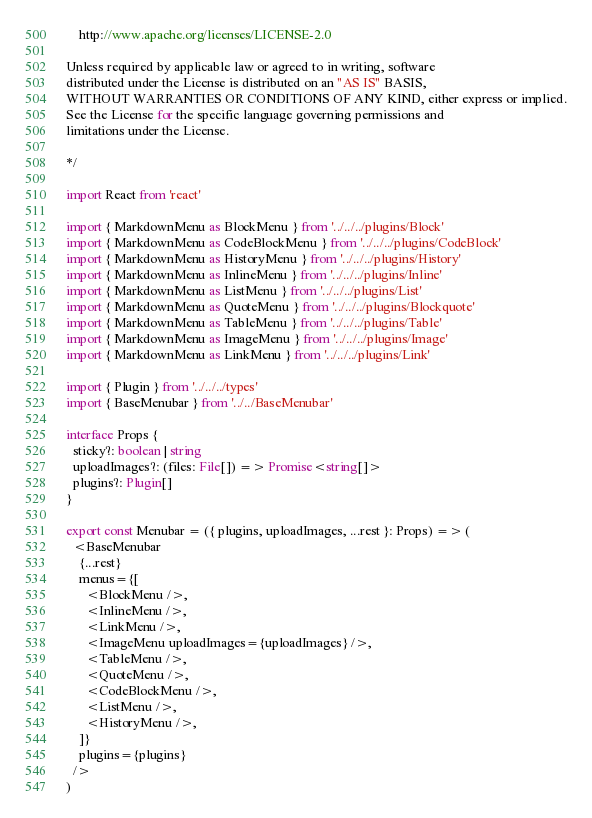<code> <loc_0><loc_0><loc_500><loc_500><_TypeScript_>    http://www.apache.org/licenses/LICENSE-2.0

Unless required by applicable law or agreed to in writing, software
distributed under the License is distributed on an "AS IS" BASIS,
WITHOUT WARRANTIES OR CONDITIONS OF ANY KIND, either express or implied.
See the License for the specific language governing permissions and
limitations under the License.

*/

import React from 'react'

import { MarkdownMenu as BlockMenu } from '../../../plugins/Block'
import { MarkdownMenu as CodeBlockMenu } from '../../../plugins/CodeBlock'
import { MarkdownMenu as HistoryMenu } from '../../../plugins/History'
import { MarkdownMenu as InlineMenu } from '../../../plugins/Inline'
import { MarkdownMenu as ListMenu } from '../../../plugins/List'
import { MarkdownMenu as QuoteMenu } from '../../../plugins/Blockquote'
import { MarkdownMenu as TableMenu } from '../../../plugins/Table'
import { MarkdownMenu as ImageMenu } from '../../../plugins/Image'
import { MarkdownMenu as LinkMenu } from '../../../plugins/Link'

import { Plugin } from '../../../types'
import { BaseMenubar } from '../../BaseMenubar'

interface Props {
  sticky?: boolean | string
  uploadImages?: (files: File[]) => Promise<string[]>
  plugins?: Plugin[]
}

export const Menubar = ({ plugins, uploadImages, ...rest }: Props) => (
  <BaseMenubar
    {...rest}
    menus={[
      <BlockMenu />,
      <InlineMenu />,
      <LinkMenu />,
      <ImageMenu uploadImages={uploadImages} />,
      <TableMenu />,
      <QuoteMenu />,
      <CodeBlockMenu />,
      <ListMenu />,
      <HistoryMenu />,
    ]}
    plugins={plugins}
  />
)
</code> 